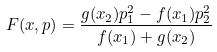Convert formula to latex. <formula><loc_0><loc_0><loc_500><loc_500>F ( x , p ) = \frac { g ( x _ { 2 } ) p _ { 1 } ^ { 2 } - f ( x _ { 1 } ) p _ { 2 } ^ { 2 } } { f ( x _ { 1 } ) + g ( x _ { 2 } ) }</formula> 